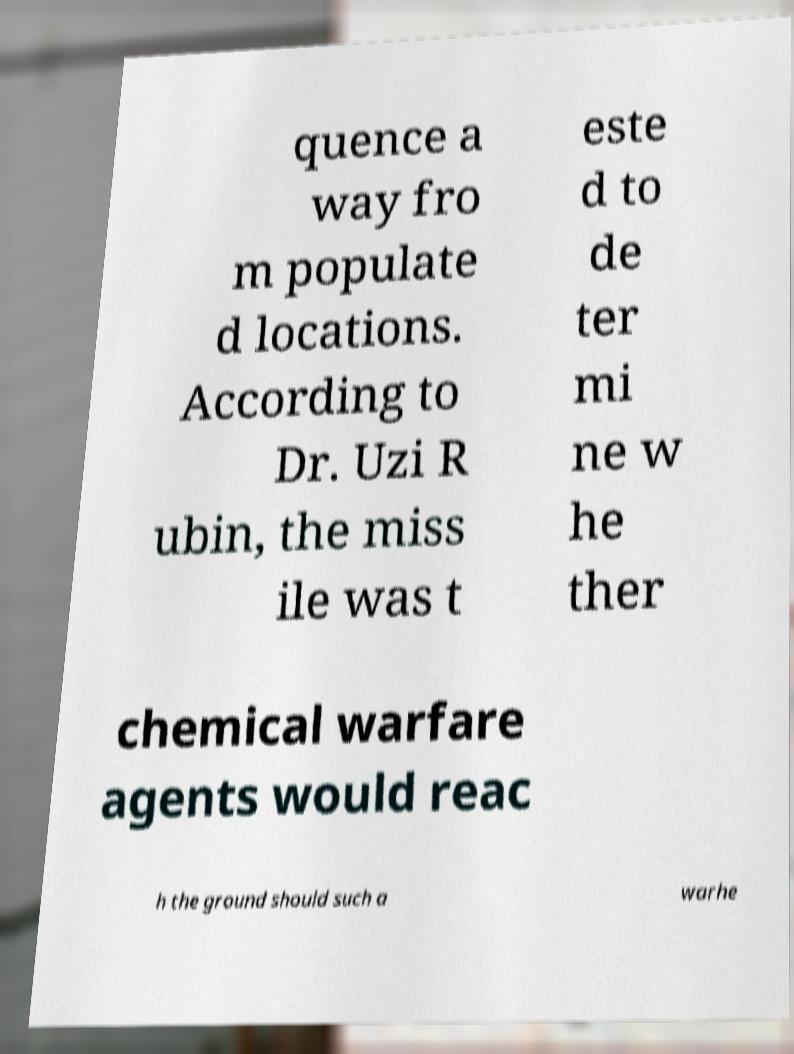Could you assist in decoding the text presented in this image and type it out clearly? quence a way fro m populate d locations. According to Dr. Uzi R ubin, the miss ile was t este d to de ter mi ne w he ther chemical warfare agents would reac h the ground should such a warhe 